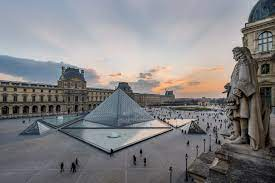What can you tell me about the history of the glass pyramid in the center? The glass pyramid in the center of the courtyard is the Louvre Pyramid, designed by architect I. M. Pei and completed in 1989. It serves as the main entrance to the Louvre Museum and is now considered one of the defining features of the area. Despite initial controversy over its modern design amidst the classical surroundings, it has become a beloved symbol of the blending of old and new within Paris' landscape. 